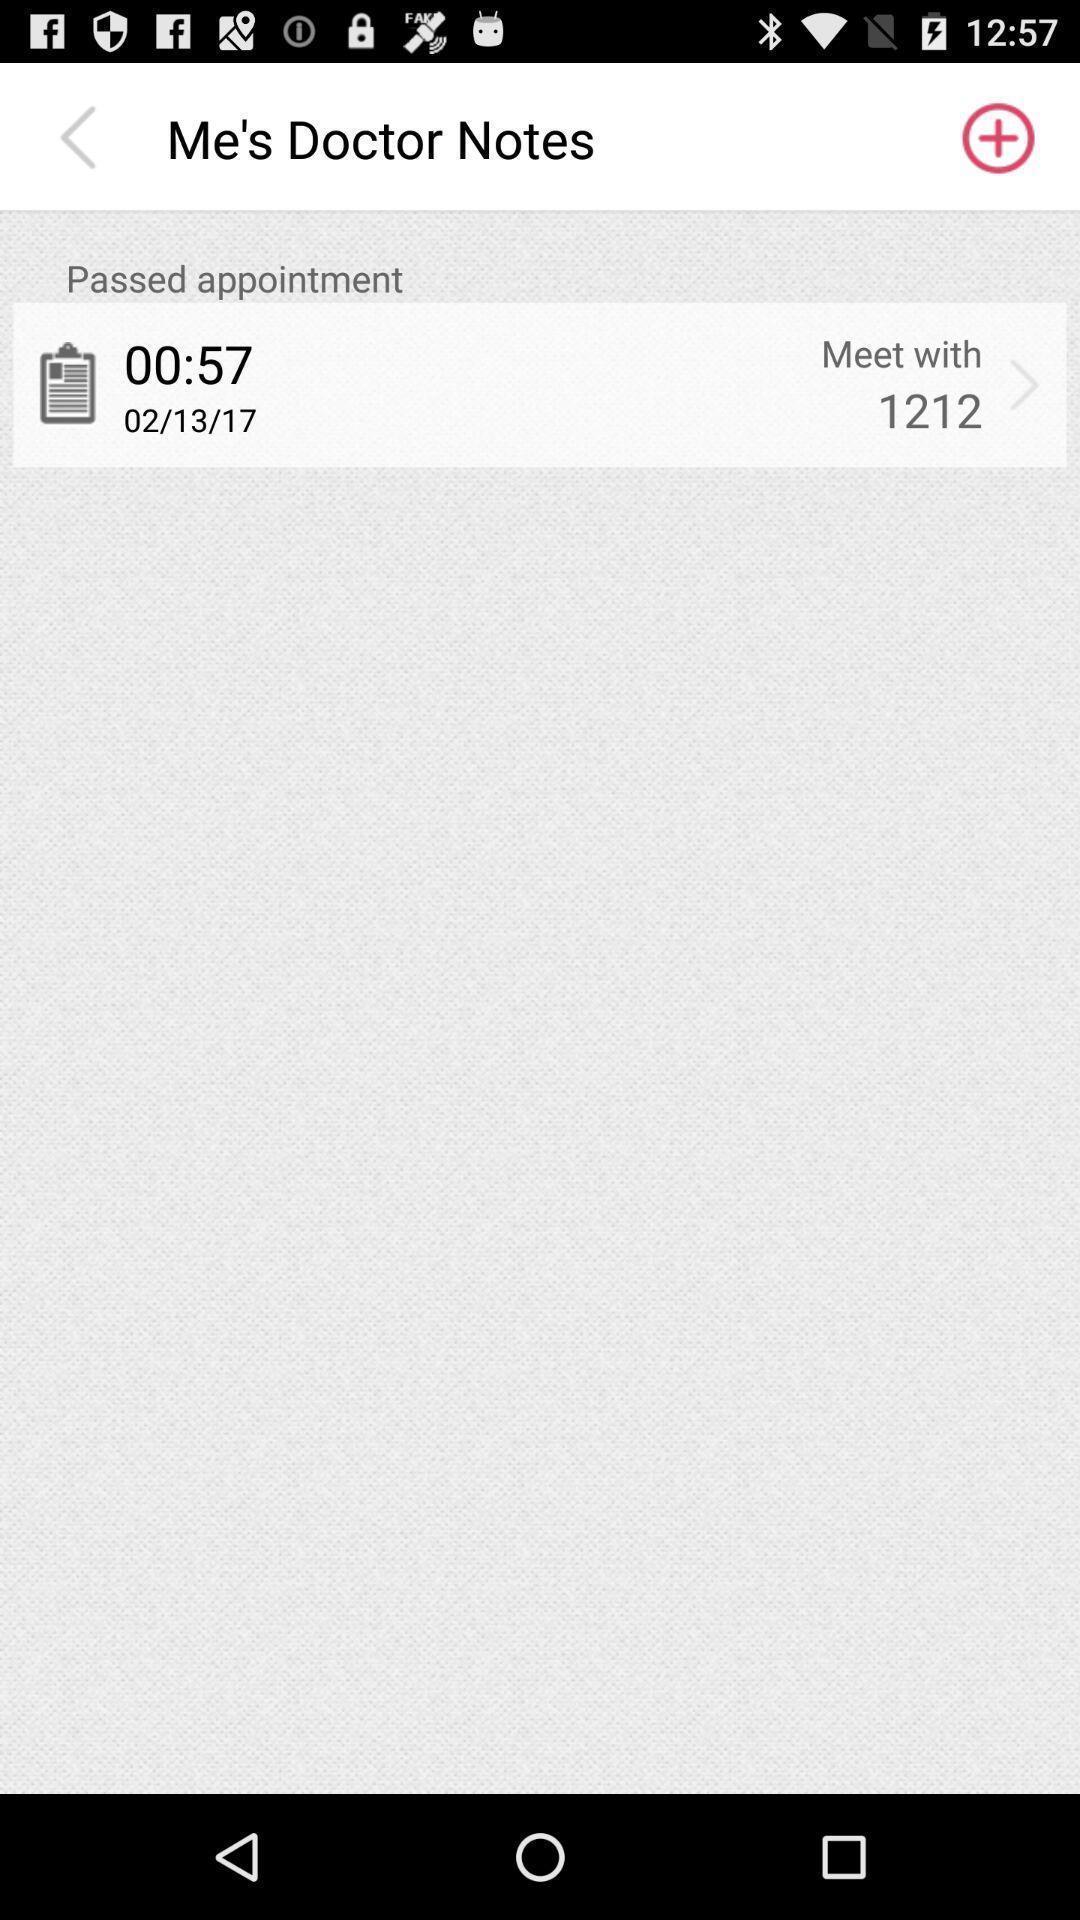Describe the key features of this screenshot. Screen shows about doctor 's meet. 